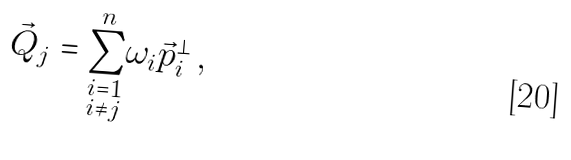Convert formula to latex. <formula><loc_0><loc_0><loc_500><loc_500>\vec { Q } _ { j } = { \sum _ { \substack { i = 1 \\ { i \ne j } } } ^ { n } } \omega _ { i } \vec { p } _ { i } ^ { \perp } \, ,</formula> 